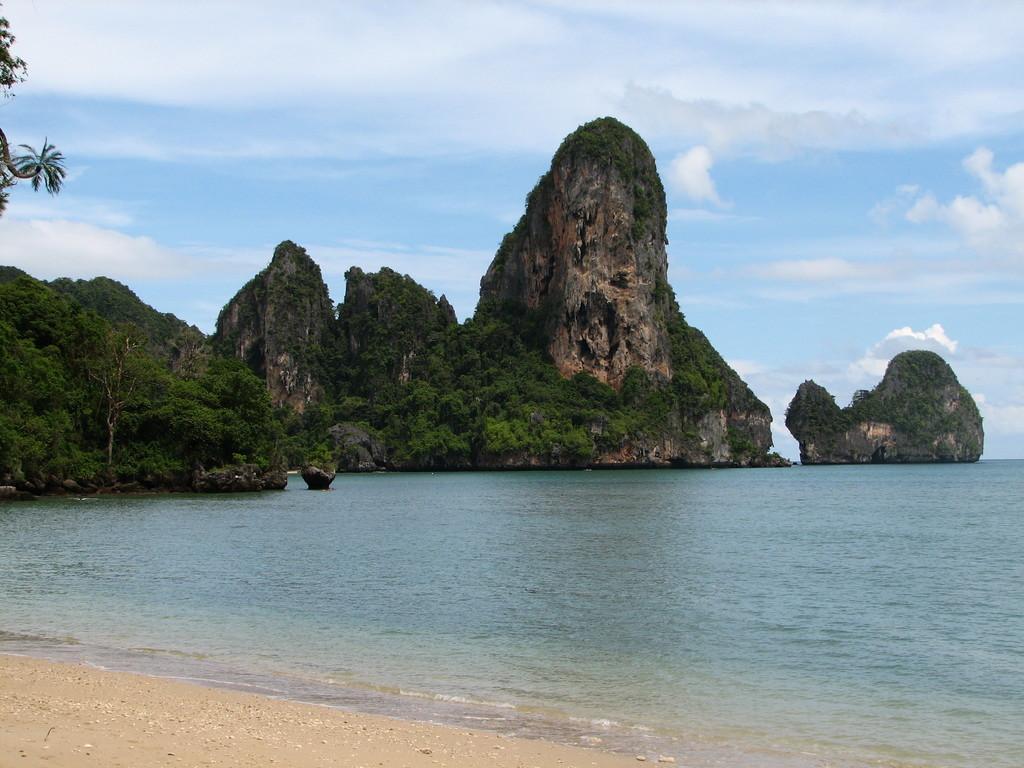In one or two sentences, can you explain what this image depicts? In this image in front there is water. In the background there are trees, rocks and sky. 